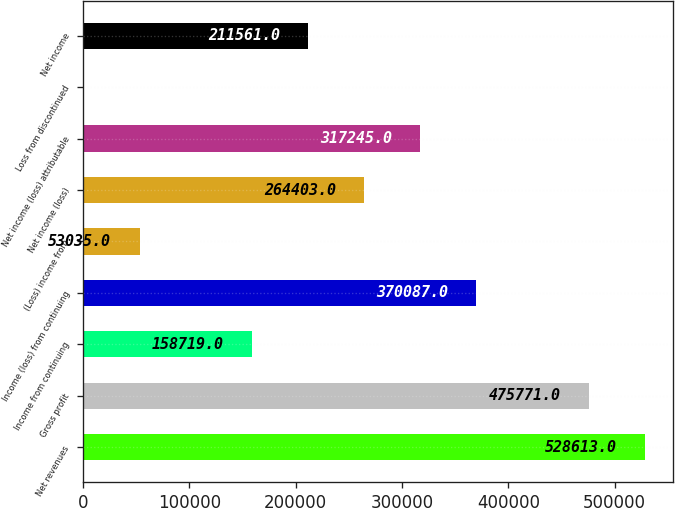Convert chart. <chart><loc_0><loc_0><loc_500><loc_500><bar_chart><fcel>Net revenues<fcel>Gross profit<fcel>Income from continuing<fcel>Income (loss) from continuing<fcel>(Loss) income from<fcel>Net income (loss)<fcel>Net income (loss) attributable<fcel>Loss from discontinued<fcel>Net income<nl><fcel>528613<fcel>475771<fcel>158719<fcel>370087<fcel>53035<fcel>264403<fcel>317245<fcel>193<fcel>211561<nl></chart> 